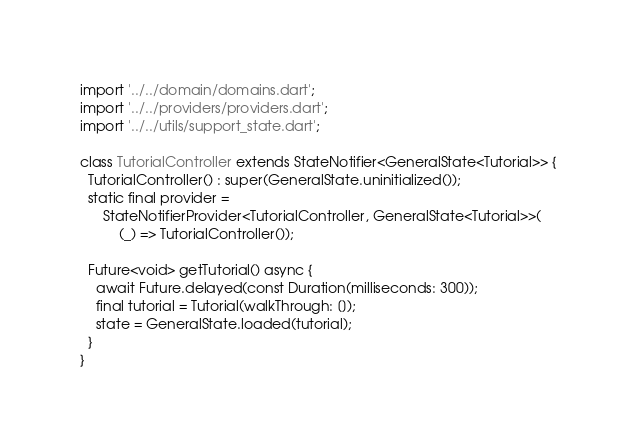Convert code to text. <code><loc_0><loc_0><loc_500><loc_500><_Dart_>import '../../domain/domains.dart';
import '../../providers/providers.dart';
import '../../utils/support_state.dart';

class TutorialController extends StateNotifier<GeneralState<Tutorial>> {
  TutorialController() : super(GeneralState.uninitialized());
  static final provider =
      StateNotifierProvider<TutorialController, GeneralState<Tutorial>>(
          (_) => TutorialController());

  Future<void> getTutorial() async {
    await Future.delayed(const Duration(milliseconds: 300));
    final tutorial = Tutorial(walkThrough: []);
    state = GeneralState.loaded(tutorial);
  }
}
</code> 